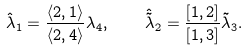<formula> <loc_0><loc_0><loc_500><loc_500>\hat { \lambda } _ { 1 } = \frac { \langle 2 , 1 \rangle } { \langle 2 , 4 \rangle } \lambda _ { 4 } , \quad \hat { \tilde { \lambda } } _ { 2 } = \frac { [ 1 , 2 ] } { [ 1 , 3 ] } \tilde { \lambda } _ { 3 } .</formula> 